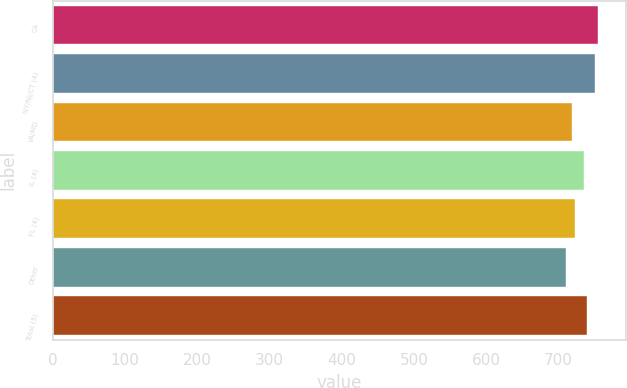Convert chart to OTSL. <chart><loc_0><loc_0><loc_500><loc_500><bar_chart><fcel>CA<fcel>NY/NJ/CT (4)<fcel>VA/MD<fcel>IL (4)<fcel>FL (4)<fcel>Other<fcel>Total (5)<nl><fcel>755.4<fcel>751<fcel>719<fcel>735<fcel>723.4<fcel>710<fcel>739.4<nl></chart> 